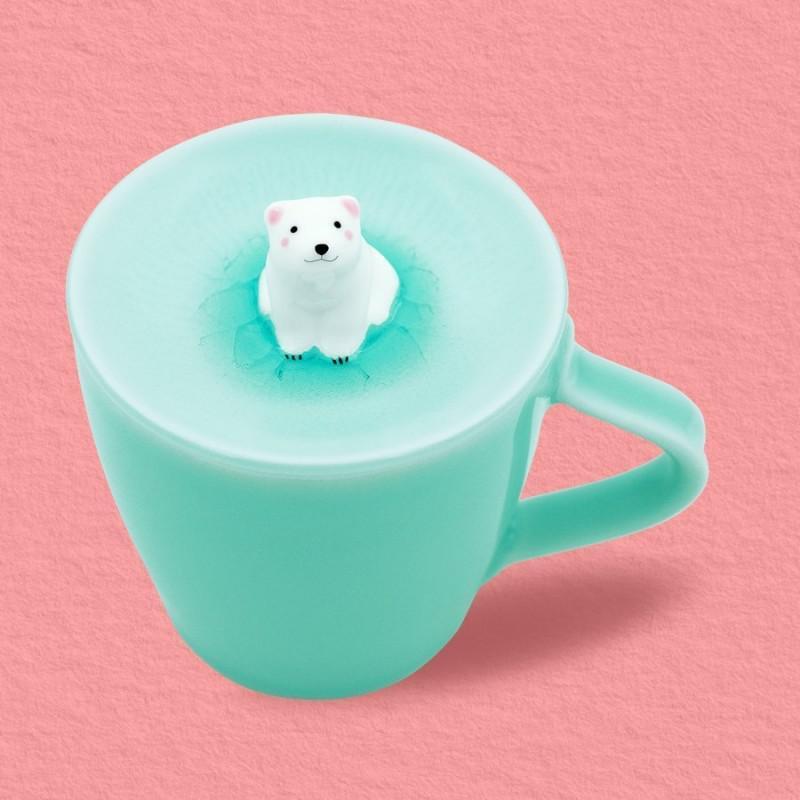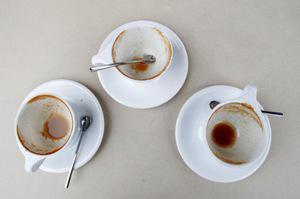The first image is the image on the left, the second image is the image on the right. Analyze the images presented: Is the assertion "An image shows a trio of gold-trimmed cup and saucer sets, including one that is robin's egg blue." valid? Answer yes or no. No. The first image is the image on the left, the second image is the image on the right. Given the left and right images, does the statement "Exactly four different cups with matching saucers are shown, three in one image and one in a second image." hold true? Answer yes or no. No. 